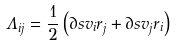<formula> <loc_0><loc_0><loc_500><loc_500>\Lambda _ { i j } = \frac { 1 } { 2 } \left ( \partial s { v _ { i } } { r _ { j } } + \partial s { v _ { j } } { r _ { i } } \right )</formula> 